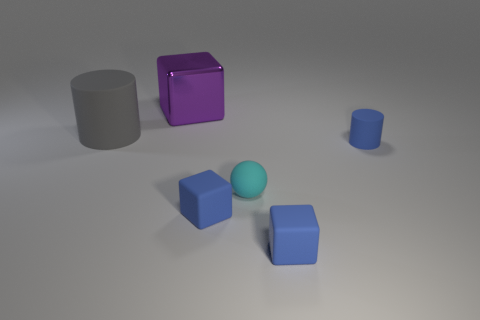Add 1 red rubber cylinders. How many objects exist? 7 Subtract all blue cylinders. How many cylinders are left? 1 Subtract all small blue blocks. How many blocks are left? 1 Subtract 0 brown cylinders. How many objects are left? 6 Subtract all balls. How many objects are left? 5 Subtract 2 cubes. How many cubes are left? 1 Subtract all yellow cylinders. Subtract all green spheres. How many cylinders are left? 2 Subtract all yellow spheres. How many gray blocks are left? 0 Subtract all blue matte things. Subtract all large gray rubber objects. How many objects are left? 2 Add 1 large gray matte things. How many large gray matte things are left? 2 